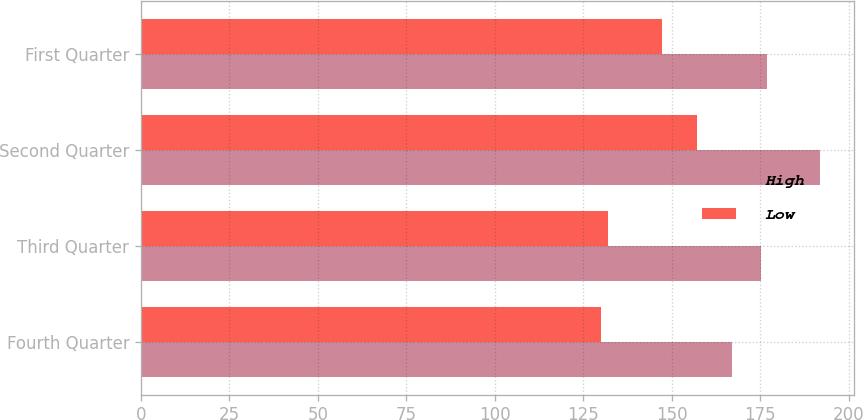Convert chart. <chart><loc_0><loc_0><loc_500><loc_500><stacked_bar_chart><ecel><fcel>Fourth Quarter<fcel>Third Quarter<fcel>Second Quarter<fcel>First Quarter<nl><fcel>High<fcel>167.13<fcel>175.28<fcel>191.95<fcel>177.07<nl><fcel>Low<fcel>130.12<fcel>131.91<fcel>157.13<fcel>147.23<nl></chart> 